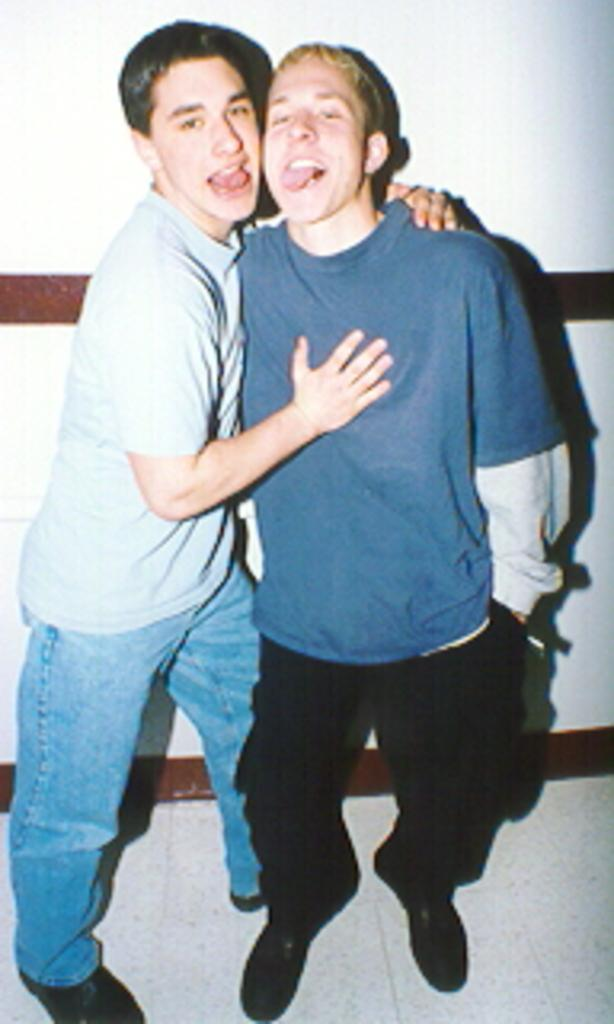Who or what is present in the image? There are people in the image. What are the people doing in the image? The people are standing with their tongues out. What can be seen behind the people in the image? There is a wall in the background of the image. What is the surface beneath the people's feet in the image? There is a floor at the bottom of the image. What type of bat is flying in the image? There is no bat present in the image. 